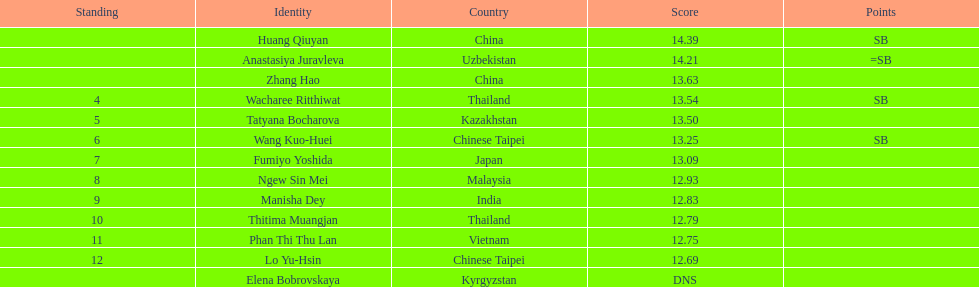Which country had the most competitors ranked in the top three in the event? China. 